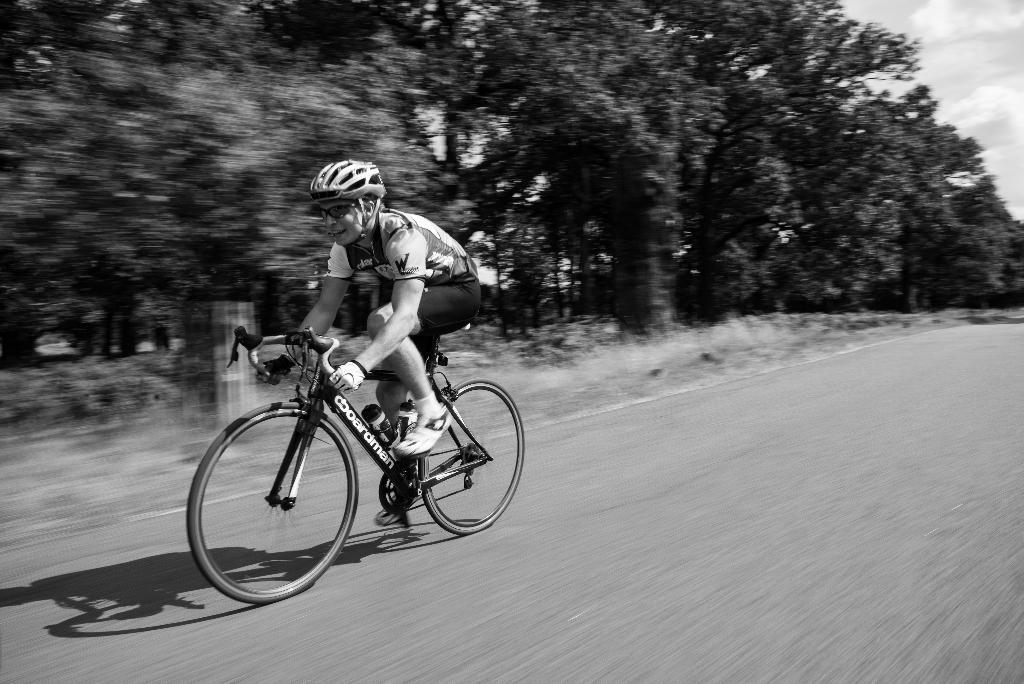How would you summarize this image in a sentence or two? This is a black and white image in this image there is one person who is sitting on a cycle and riding. At the bottom there is road, and in the background there are some trees and sky. 